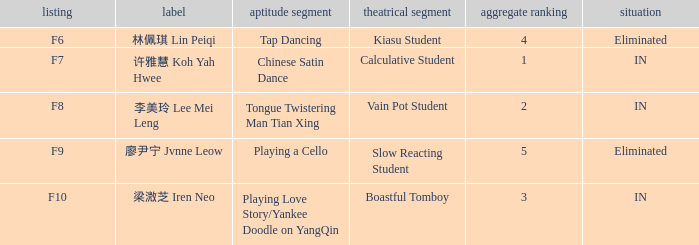For the event with index f9, what's the talent segment? Playing a Cello. 